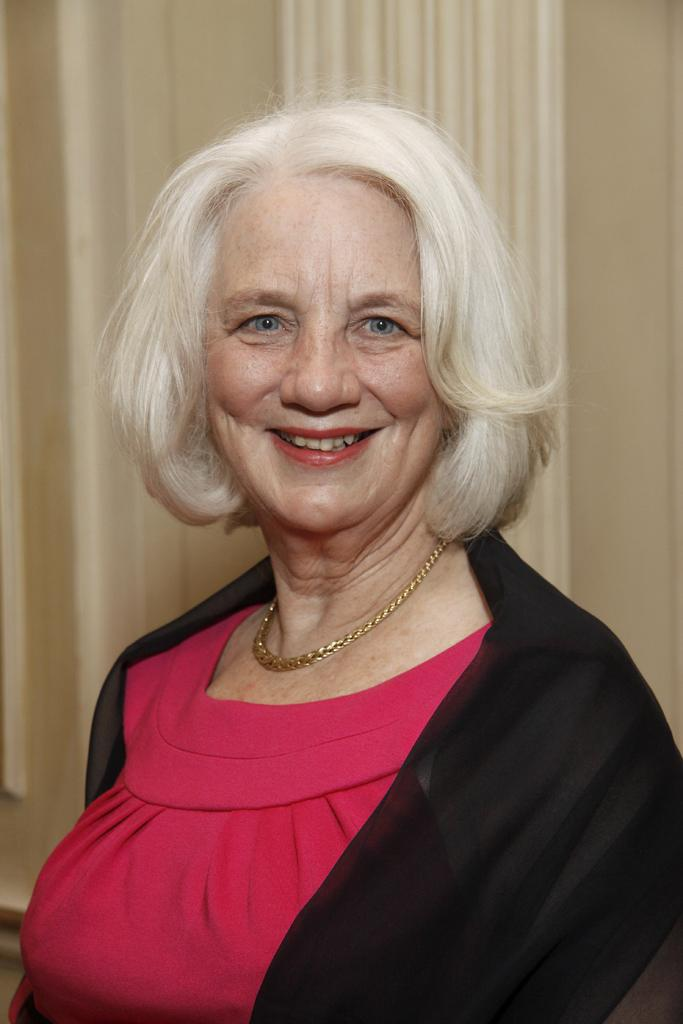Who is the main subject in the image? There is an old woman in the image. What is the old woman doing in the image? The old woman is smiling. What color is the top the old woman is wearing? The old woman is wearing a pink top. What type of outerwear is the old woman wearing? The old woman is wearing a black coat. What can be seen behind the old woman? There is a curtain behind the old woman. What is on the right side of the image? There is a wall on the right side of the image. What type of lace can be seen on the old woman's clothing in the image? There is no lace visible on the old woman's clothing in the image. Is the old woman in a hospital in the image? There is no indication in the image that the old woman is in a hospital. 